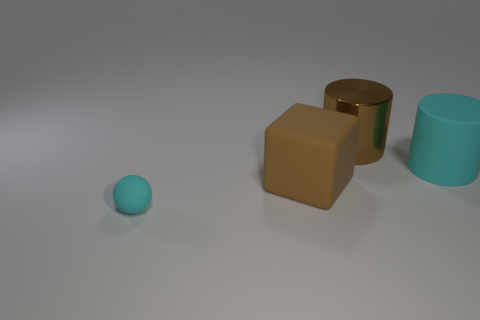What number of big cyan cylinders are the same material as the cube?
Offer a very short reply. 1. Do the cyan thing left of the big brown metal cylinder and the brown object that is to the right of the large rubber cube have the same size?
Offer a very short reply. No. What color is the large cube in front of the big brown object that is behind the cyan rubber thing behind the small cyan matte sphere?
Ensure brevity in your answer.  Brown. Are there any other brown matte objects that have the same shape as the small matte object?
Your answer should be compact. No. Are there an equal number of metal cylinders behind the big brown metallic object and brown metal cylinders on the left side of the small object?
Provide a short and direct response. Yes. Do the cyan rubber thing in front of the big cyan matte thing and the big cyan rubber thing have the same shape?
Provide a succinct answer. No. Is the brown matte object the same shape as the large brown shiny thing?
Keep it short and to the point. No. What number of rubber things are either cyan objects or large brown cylinders?
Provide a succinct answer. 2. What is the material of the big cylinder that is the same color as the small thing?
Your answer should be compact. Rubber. Is the size of the cyan sphere the same as the metallic object?
Give a very brief answer. No. 